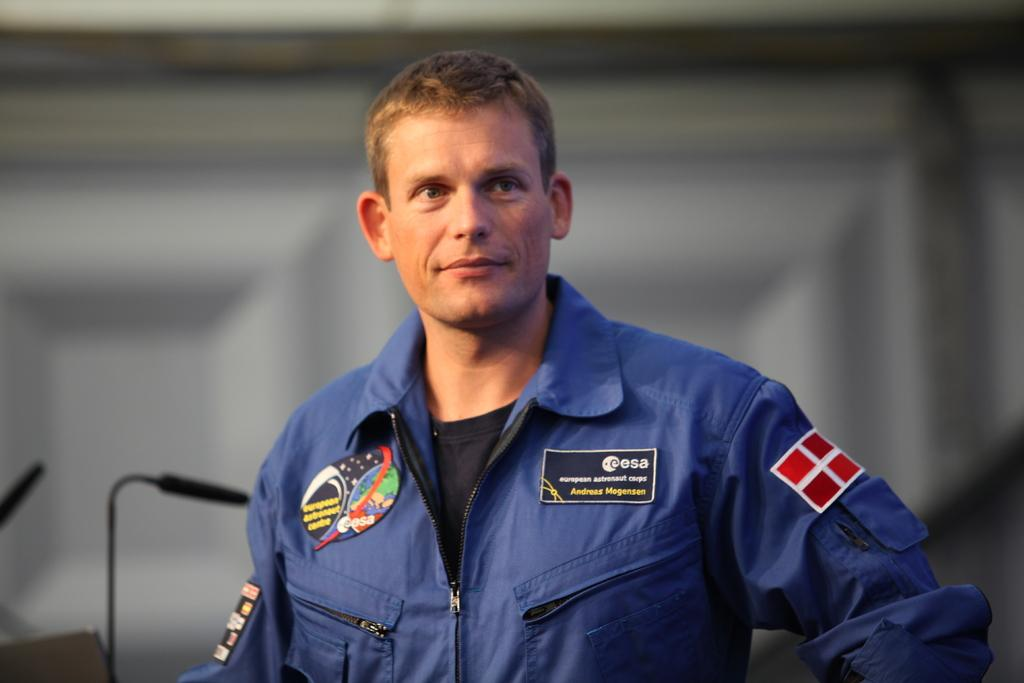Who is the main subject in the image? There is a man in the center of the image. What can be seen in the background of the image? There are mice and a door in the background of the image. What type of yard can be seen in the image? There is no yard present in the image. 